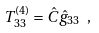<formula> <loc_0><loc_0><loc_500><loc_500>T ^ { ( 4 ) } _ { 3 3 } = { \hat { C } } { \hat { g } } _ { 3 3 } \ ,</formula> 